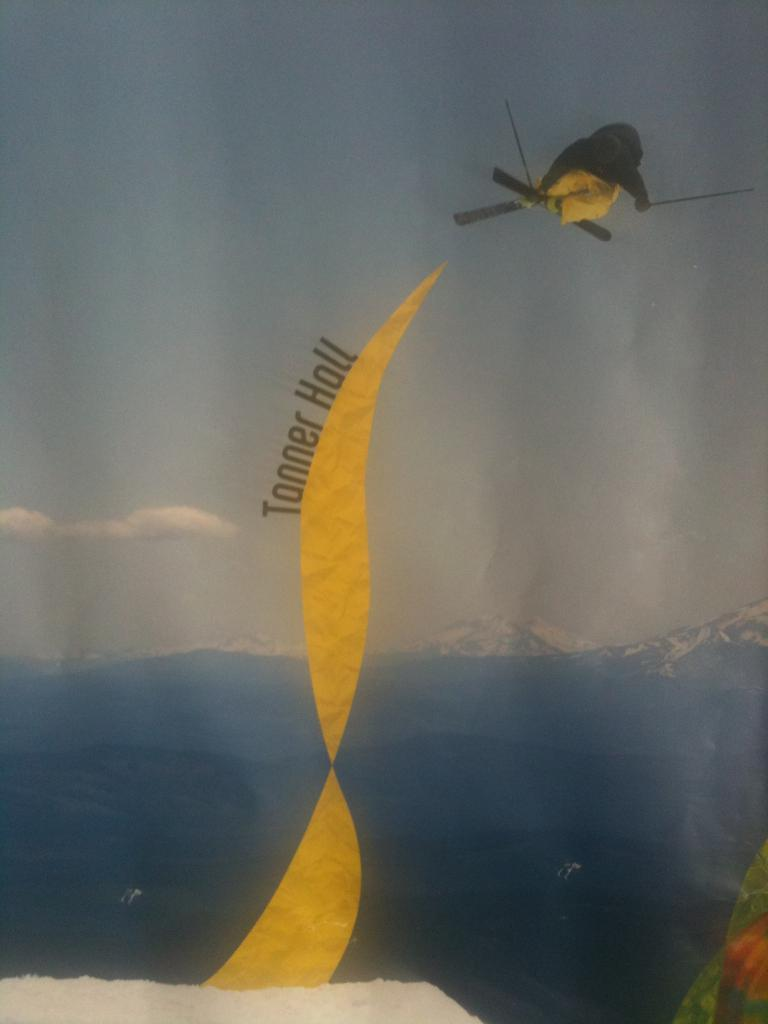What is featured on the poster in the image? The poster contains an image of a sea. What else can be seen in the sky in the image? The sky with clouds is visible in the image. What is the purpose of the parachute in the image? The purpose of the parachute in the image is not clear, but it might be related to skydiving or a similar activity. What is written on the poster? There is text on the poster. Where is the meeting taking place in the image? There is no meeting present in the image. Can you tell me how many lakes are visible in the image? The image does not contain any lakes; it features a poster with an image of a sea. 